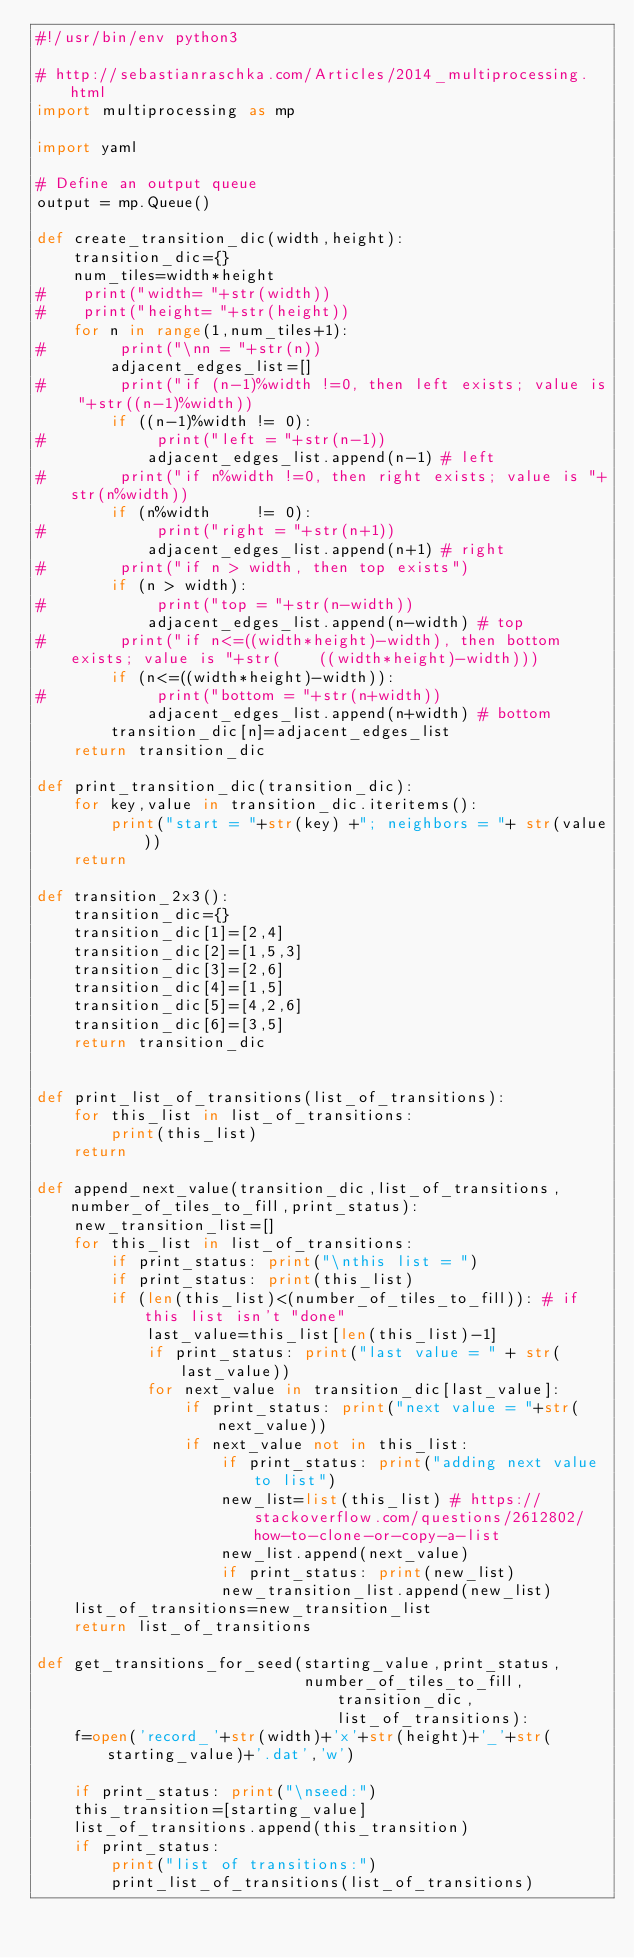Convert code to text. <code><loc_0><loc_0><loc_500><loc_500><_Python_>#!/usr/bin/env python3

# http://sebastianraschka.com/Articles/2014_multiprocessing.html
import multiprocessing as mp

import yaml

# Define an output queue
output = mp.Queue()

def create_transition_dic(width,height):
    transition_dic={}
    num_tiles=width*height
#    print("width= "+str(width))
#    print("height= "+str(height))
    for n in range(1,num_tiles+1):
#        print("\nn = "+str(n))
        adjacent_edges_list=[]
#        print("if (n-1)%width !=0, then left exists; value is "+str((n-1)%width))
        if ((n-1)%width != 0):
#            print("left = "+str(n-1))
            adjacent_edges_list.append(n-1) # left
#        print("if n%width !=0, then right exists; value is "+str(n%width))
        if (n%width     != 0):
#            print("right = "+str(n+1))
            adjacent_edges_list.append(n+1) # right
#        print("if n > width, then top exists")
        if (n > width):
#            print("top = "+str(n-width))
            adjacent_edges_list.append(n-width) # top
#        print("if n<=((width*height)-width), then bottom exists; value is "+str(    ((width*height)-width)))
        if (n<=((width*height)-width)):
#            print("bottom = "+str(n+width))
            adjacent_edges_list.append(n+width) # bottom
        transition_dic[n]=adjacent_edges_list
    return transition_dic

def print_transition_dic(transition_dic):
    for key,value in transition_dic.iteritems():
        print("start = "+str(key) +"; neighbors = "+ str(value))
    return

def transition_2x3():
    transition_dic={}
    transition_dic[1]=[2,4]
    transition_dic[2]=[1,5,3]
    transition_dic[3]=[2,6]
    transition_dic[4]=[1,5]
    transition_dic[5]=[4,2,6]
    transition_dic[6]=[3,5]
    return transition_dic


def print_list_of_transitions(list_of_transitions):
    for this_list in list_of_transitions:
        print(this_list)
    return

def append_next_value(transition_dic,list_of_transitions,number_of_tiles_to_fill,print_status):
    new_transition_list=[]
    for this_list in list_of_transitions:
        if print_status: print("\nthis list = ")
        if print_status: print(this_list)
        if (len(this_list)<(number_of_tiles_to_fill)): # if this list isn't "done"
            last_value=this_list[len(this_list)-1]
            if print_status: print("last value = " + str(last_value))
            for next_value in transition_dic[last_value]:
                if print_status: print("next value = "+str(next_value))
                if next_value not in this_list:
                    if print_status: print("adding next value to list")
                    new_list=list(this_list) # https://stackoverflow.com/questions/2612802/how-to-clone-or-copy-a-list
                    new_list.append(next_value)
                    if print_status: print(new_list)
                    new_transition_list.append(new_list)
    list_of_transitions=new_transition_list
    return list_of_transitions

def get_transitions_for_seed(starting_value,print_status,
                             number_of_tiles_to_fill,transition_dic,list_of_transitions):
    f=open('record_'+str(width)+'x'+str(height)+'_'+str(starting_value)+'.dat','w')

    if print_status: print("\nseed:")
    this_transition=[starting_value]
    list_of_transitions.append(this_transition)
    if print_status:
        print("list of transitions:")
        print_list_of_transitions(list_of_transitions)
</code> 